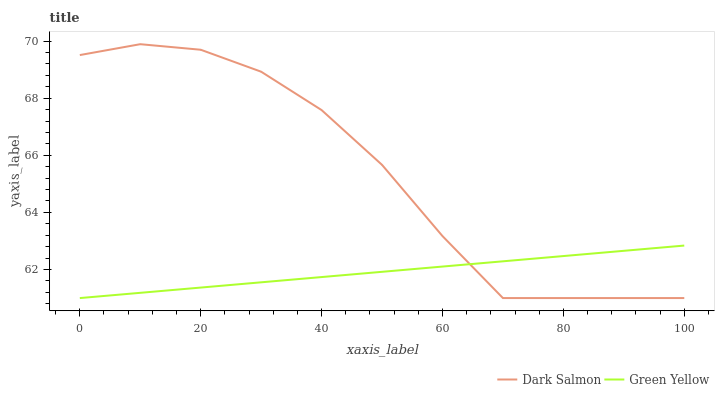Does Green Yellow have the minimum area under the curve?
Answer yes or no. Yes. Does Dark Salmon have the maximum area under the curve?
Answer yes or no. Yes. Does Dark Salmon have the minimum area under the curve?
Answer yes or no. No. Is Green Yellow the smoothest?
Answer yes or no. Yes. Is Dark Salmon the roughest?
Answer yes or no. Yes. Is Dark Salmon the smoothest?
Answer yes or no. No. Does Green Yellow have the lowest value?
Answer yes or no. Yes. Does Dark Salmon have the highest value?
Answer yes or no. Yes. Does Green Yellow intersect Dark Salmon?
Answer yes or no. Yes. Is Green Yellow less than Dark Salmon?
Answer yes or no. No. Is Green Yellow greater than Dark Salmon?
Answer yes or no. No. 